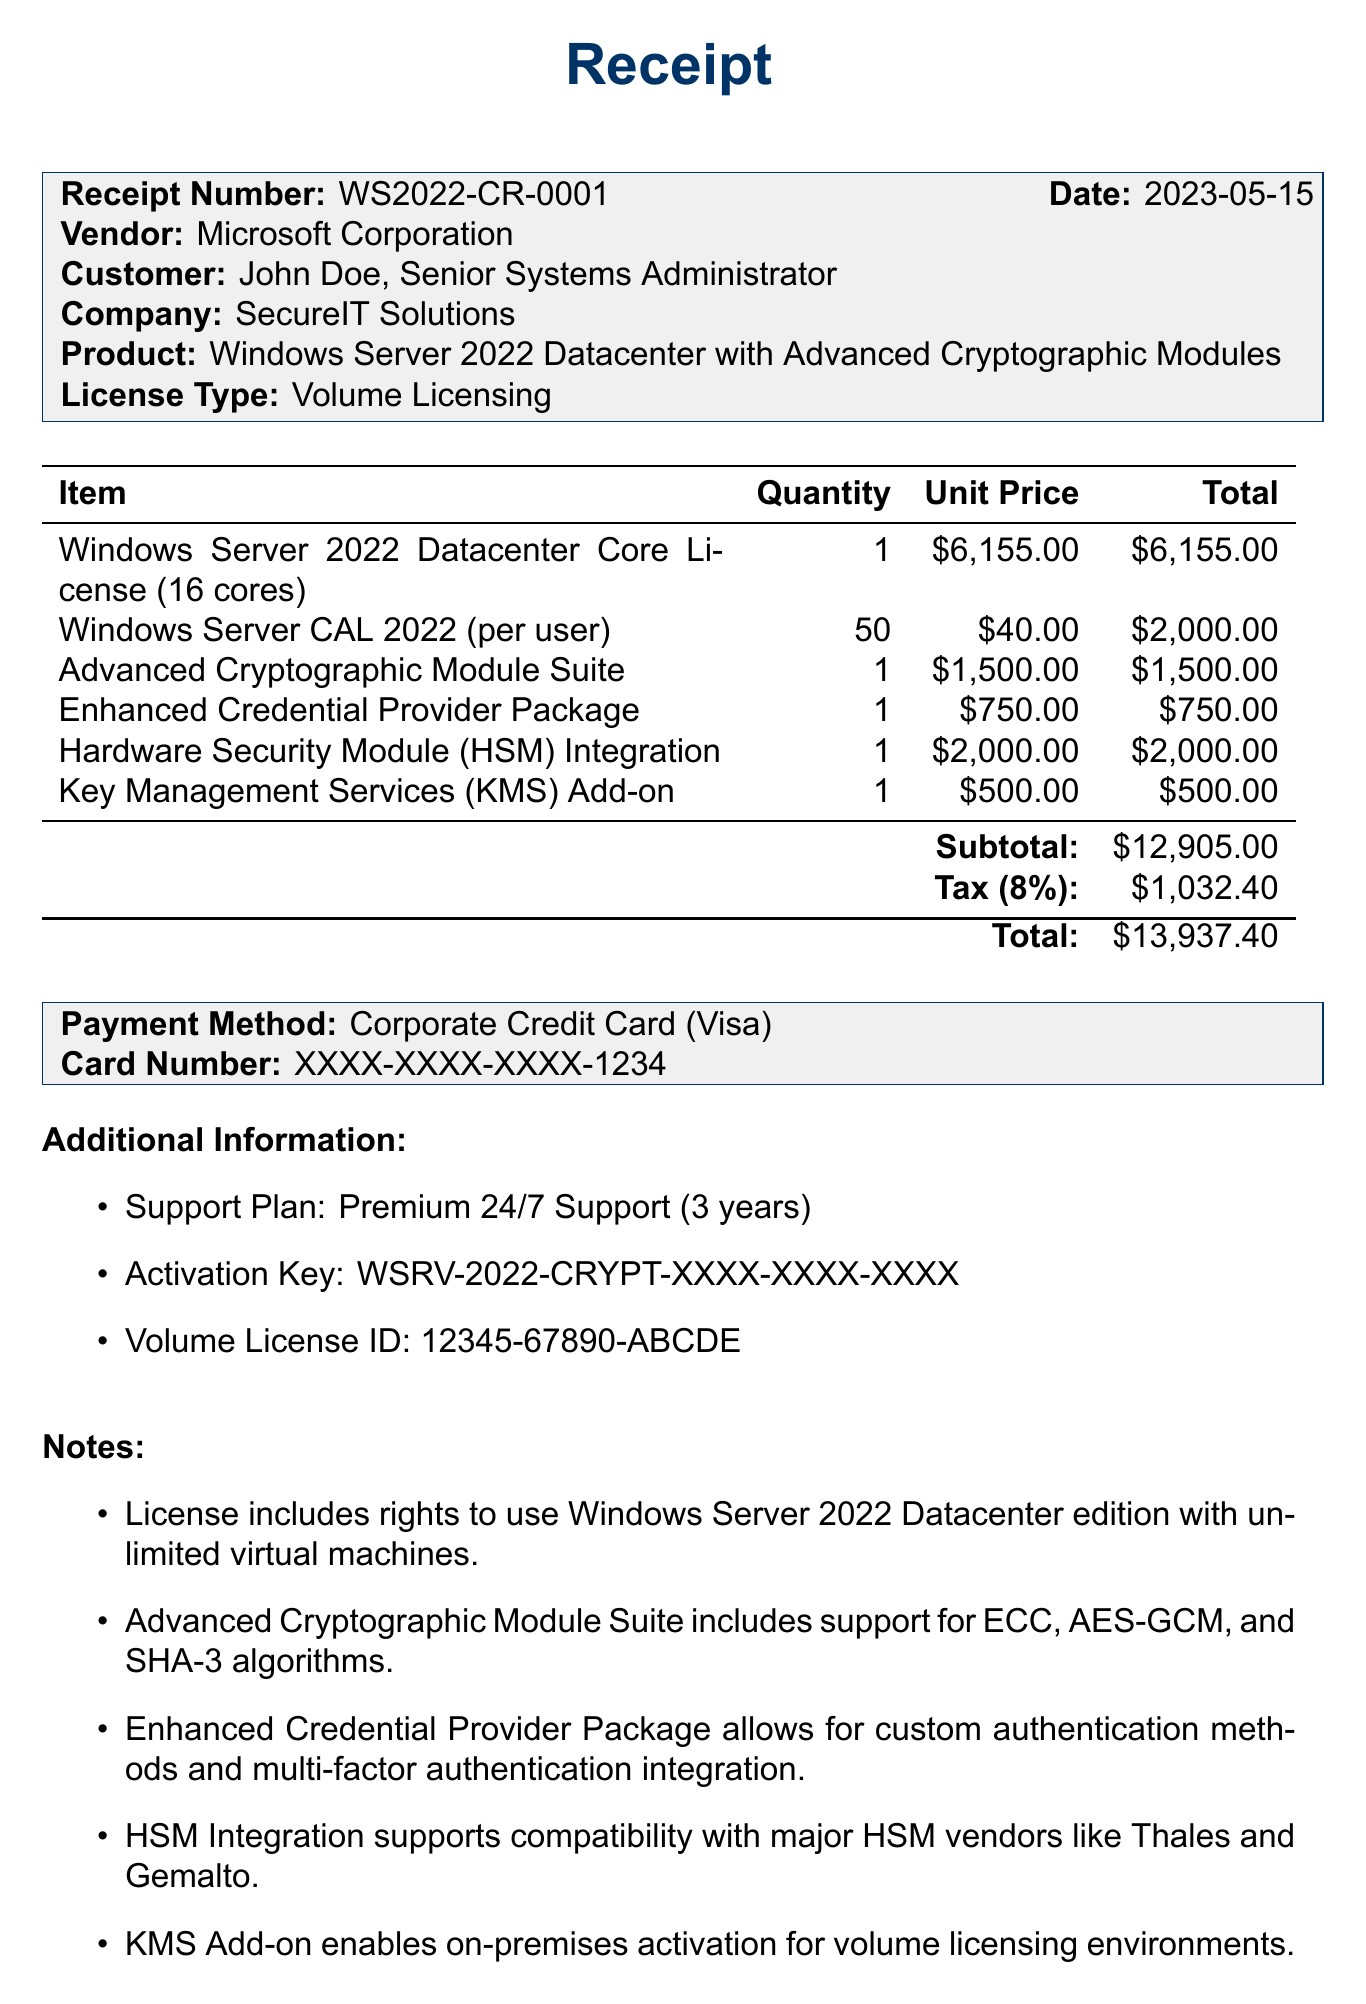What is the receipt number? The receipt number is clearly stated at the top of the document.
Answer: WS2022-CR-0001 What is the total amount paid? The total amount is provided at the end of the receipt.
Answer: $13,937.40 Who is the customer? The customer's name and position are mentioned in the customer section.
Answer: John Doe What date was the license purchased? The purchase date is listed directly following the receipt number.
Answer: 2023-05-15 How many Windows Server CAL 2022 licenses were purchased? The quantity of CAL licenses is detailed in the items list of the receipt.
Answer: 50 What is included in the Advanced Cryptographic Module Suite? This detail is presented in the notes section of the document.
Answer: ECC, AES-GCM, and SHA-3 algorithms What payment method was used? The payment method is specified in the payment method section of the receipt.
Answer: Corporate Credit Card What type of support plan is included? The support plan details are given in the additional information section.
Answer: Premium 24/7 Support How long is the support duration? The duration for support is noted in the additional information section.
Answer: 3 years 